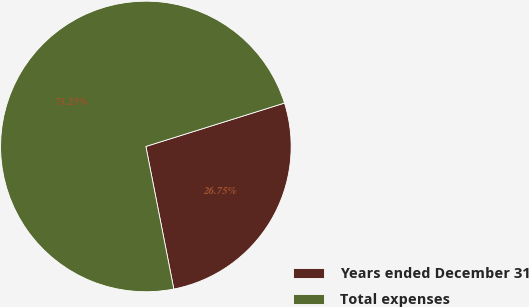Convert chart to OTSL. <chart><loc_0><loc_0><loc_500><loc_500><pie_chart><fcel>Years ended December 31<fcel>Total expenses<nl><fcel>26.75%<fcel>73.25%<nl></chart> 